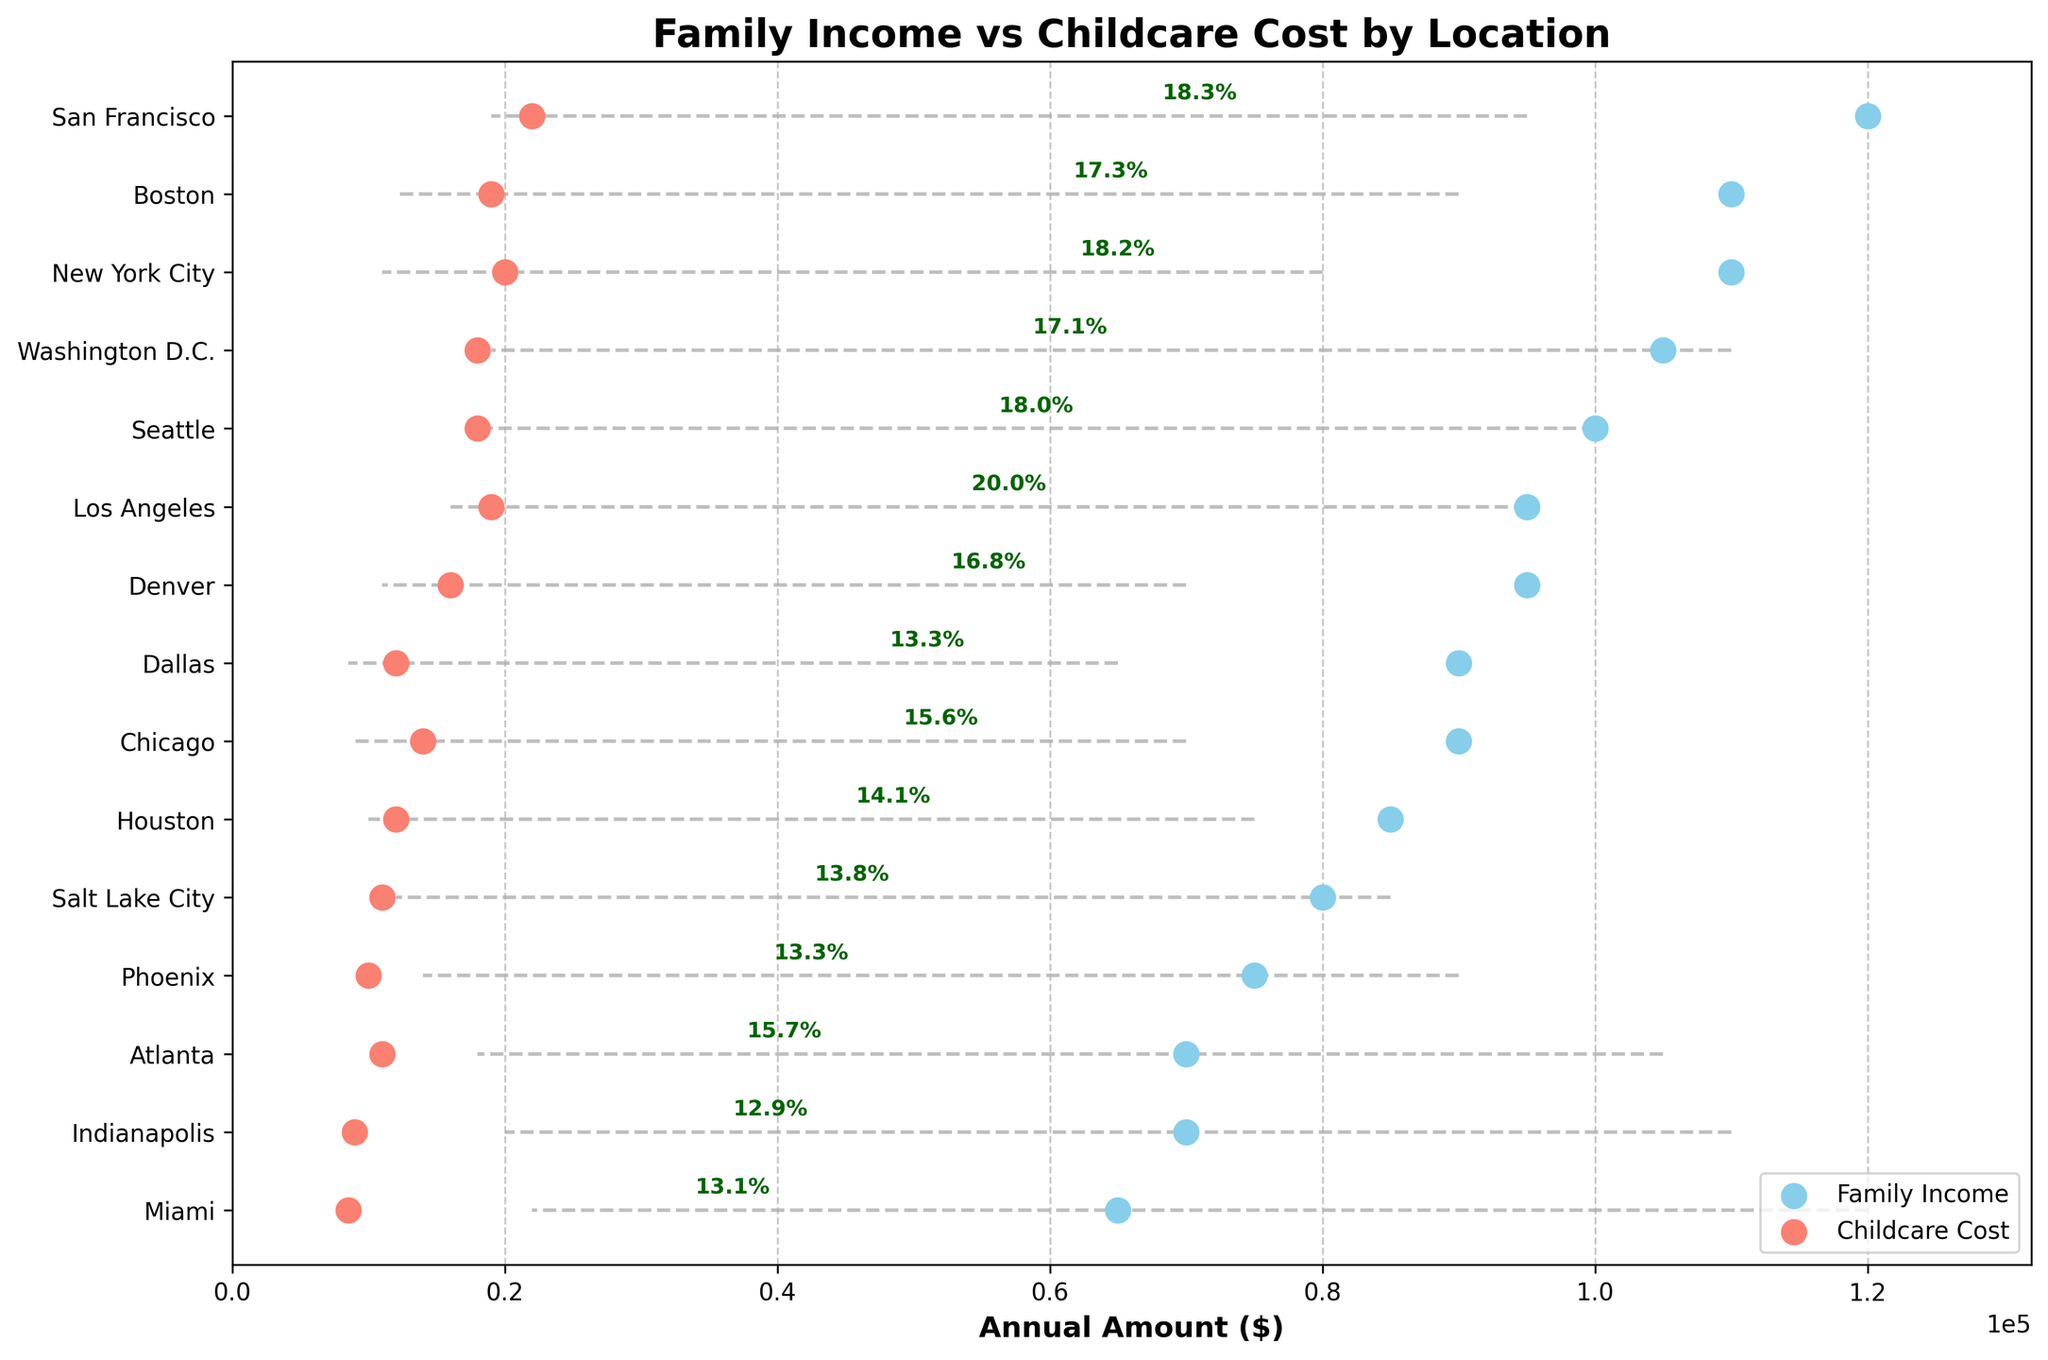What's the title of the plot? The title is positioned at the top of the plot and is written in bold text.
Answer: Family Income vs Childcare Cost by Location What is the median family income in New York City? Locate New York City on the y-axis, then look at the corresponding value on the x-axis for family income, represented by a sky blue dot.
Answer: $110,000 Which city has the highest annual childcare cost? Identify the city with the highest childcare cost by finding the furthest right red dot on the x-axis.
Answer: Los Angeles What percentage of income is spent on childcare in Boston? Locate Boston on the y-axis and find the percentage label annotated next to the connecting line between sky blue and red dots.
Answer: 17.27% How much more does childcare cost in San Francisco compared to Miami? Subtract the childcare cost in Miami from the childcare cost in San Francisco. Look at the x-axis values for comparison.
Answer: $22,000 - $8,500 = $13,500 Between which cities is there the smallest difference in the percentage of income spent on childcare? Compare the annotated percentage labels next to the connecting lines for each city, focusing on finding the smallest difference.
Answer: New York City and Washington D.C. (18.18% vs 17.14%) What is the range of family incomes across all locations? Find the sky blue dots representing the lowest and highest family incomes on the x-axis and subtract the smallest value from the largest.
Answer: $120,000 (San Francisco) - $65,000 (Miami) = $55,000 Which city has the highest percentage of income spent on childcare and what is it? Look for the highest percentage annotated next to any of the connecting lines.
Answer: Los Angeles, 20.00% How does the childcare cost in Houston compare to Atlanta? Locate Houston and Atlanta on the y-axis, and compare the red dot positions on the x-axis for each city.
Answer: Houston: $12,000, Atlanta: $11,000 What's the average childcare cost across all cities? Add up all the childcare costs and divide by the number of cities (15 cities in total). This requires the summation of all childcare costs: $22,000 + $20,000 + $18,000 + $14,000 + $12,000 + $10,000 + $9,000 + $8,500 + $11,000 + $16,000 + $18,000 + $19,000 + $11,000 + $12,000 + $19,000 = $200,500. Then divide by 15
Answer: $200,500 / 15 = $13,367 